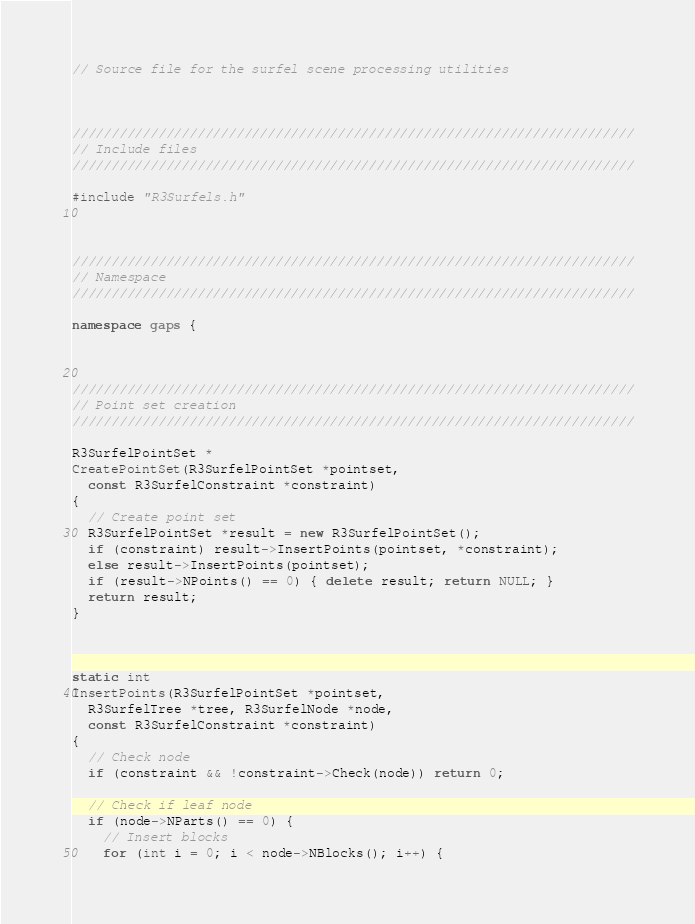<code> <loc_0><loc_0><loc_500><loc_500><_C++_>// Source file for the surfel scene processing utilities



////////////////////////////////////////////////////////////////////////
// Include files
////////////////////////////////////////////////////////////////////////

#include "R3Surfels.h"



////////////////////////////////////////////////////////////////////////
// Namespace
////////////////////////////////////////////////////////////////////////

namespace gaps {



////////////////////////////////////////////////////////////////////////
// Point set creation
////////////////////////////////////////////////////////////////////////

R3SurfelPointSet *
CreatePointSet(R3SurfelPointSet *pointset, 
  const R3SurfelConstraint *constraint)
{
  // Create point set
  R3SurfelPointSet *result = new R3SurfelPointSet();
  if (constraint) result->InsertPoints(pointset, *constraint);
  else result->InsertPoints(pointset);
  if (result->NPoints() == 0) { delete result; return NULL; }
  return result;
}



static int
InsertPoints(R3SurfelPointSet *pointset, 
  R3SurfelTree *tree, R3SurfelNode *node,
  const R3SurfelConstraint *constraint)
{
  // Check node
  if (constraint && !constraint->Check(node)) return 0;

  // Check if leaf node
  if (node->NParts() == 0) {
    // Insert blocks
    for (int i = 0; i < node->NBlocks(); i++) {</code> 